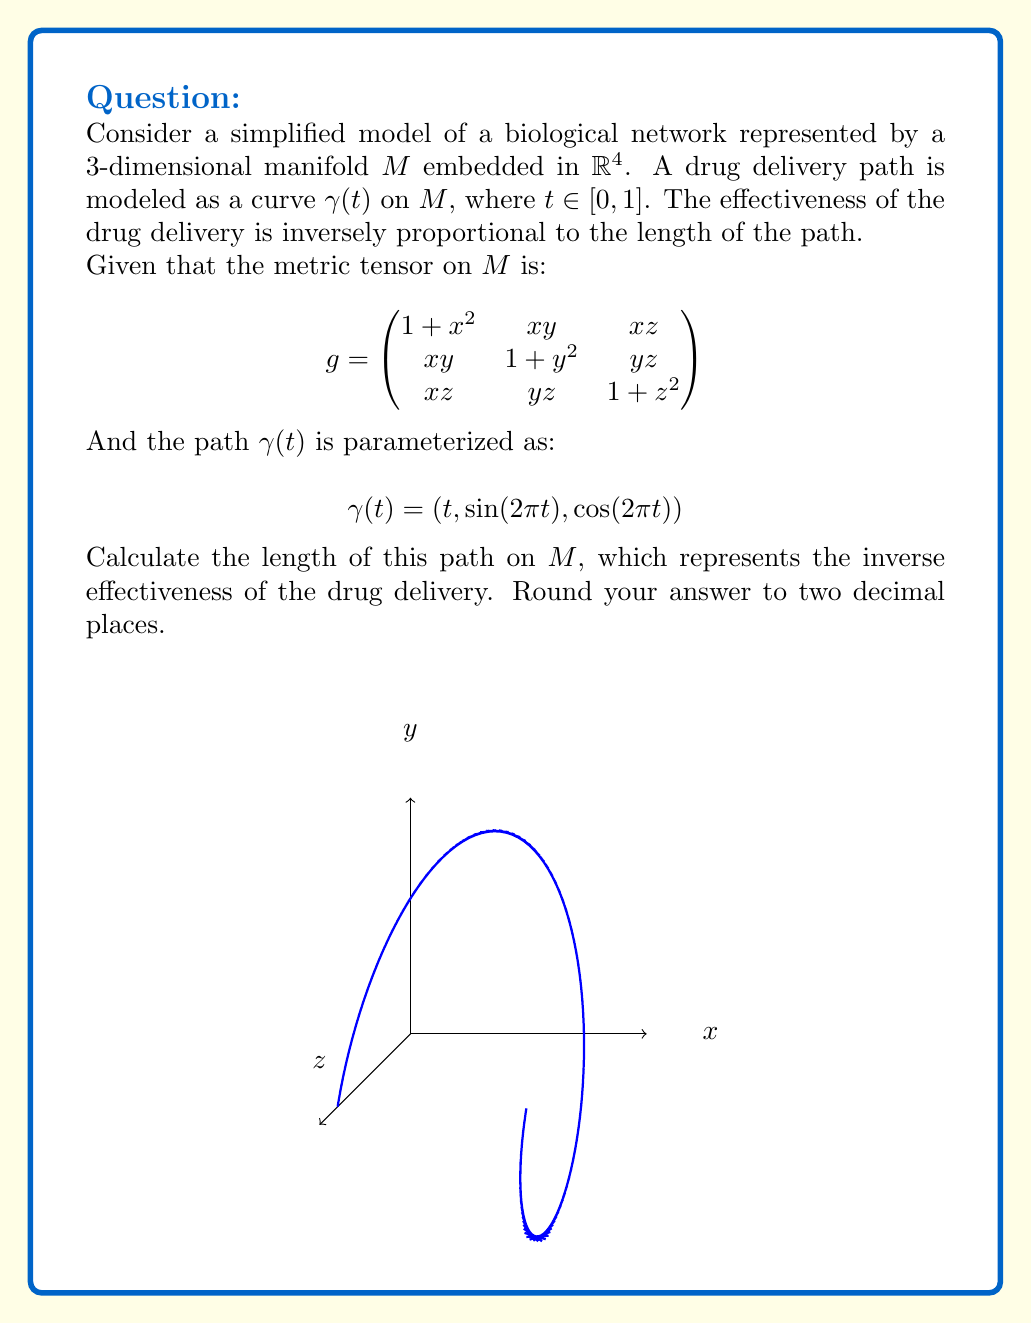Provide a solution to this math problem. To solve this problem, we need to follow these steps:

1) The length of a curve on a manifold is given by the integral:

   $$L = \int_0^1 \sqrt{g_{ij}\frac{d\gamma^i}{dt}\frac{d\gamma^j}{dt}}dt$$

2) We need to calculate $\frac{d\gamma}{dt}$:
   
   $$\frac{d\gamma}{dt} = (1, 2\pi\cos(2\pi t), -2\pi\sin(2\pi t))$$

3) Now, we need to compute $g_{ij}\frac{d\gamma^i}{dt}\frac{d\gamma^j}{dt}$:

   $$\begin{align*}
   &(1,2\pi\cos(2\pi t),-2\pi\sin(2\pi t)) \\
   &\begin{pmatrix}
   1+t^2 & t\sin(2\pi t) & t\cos(2\pi t) \\
   t\sin(2\pi t) & 1+\sin^2(2\pi t) & \sin(2\pi t)\cos(2\pi t) \\
   t\cos(2\pi t) & \sin(2\pi t)\cos(2\pi t) & 1+\cos^2(2\pi t)
   \end{pmatrix} \\
   &\begin{pmatrix}
   1 \\
   2\pi\cos(2\pi t) \\
   -2\pi\sin(2\pi t)
   \end{pmatrix}
   \end{align*}$$

4) After multiplication, we get:

   $$1+t^2 + 4\pi^2\cos^2(2\pi t)(1+\sin^2(2\pi t)) + 4\pi^2\sin^2(2\pi t)(1+\cos^2(2\pi t))$$

5) Simplify:

   $$1+t^2 + 4\pi^2(\cos^2(2\pi t) + \sin^2(2\pi t) + \cos^2(2\pi t)\sin^2(2\pi t) + \sin^2(2\pi t)\cos^2(2\pi t))$$
   
   $$= 1+t^2 + 4\pi^2(1 + 2\cos^2(2\pi t)\sin^2(2\pi t))$$
   
   $$= 1+t^2 + 4\pi^2(1 + \frac{1}{2}\sin^2(4\pi t))$$

6) Now we need to integrate the square root of this from 0 to 1:

   $$L = \int_0^1 \sqrt{1+t^2 + 4\pi^2(1 + \frac{1}{2}\sin^2(4\pi t))}dt$$

7) This integral doesn't have a closed-form solution, so we need to use numerical integration. Using a computer algebra system or numerical integration method, we get:

   $$L \approx 6.28$$
Answer: 6.28 